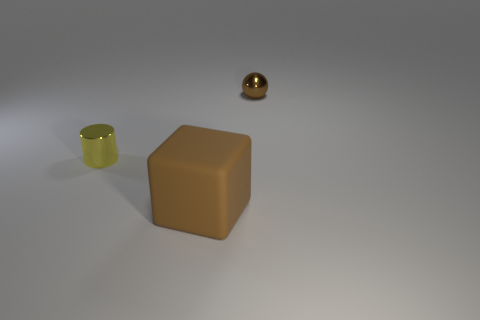What is the color of the object that is both right of the cylinder and behind the block?
Your response must be concise. Brown. Do the tiny object to the left of the small brown metallic thing and the small object on the right side of the tiny yellow metallic cylinder have the same material?
Give a very brief answer. Yes. Do the brown thing behind the yellow metallic cylinder and the small yellow metal cylinder have the same size?
Provide a short and direct response. Yes. Does the large thing have the same color as the metal object on the right side of the matte block?
Ensure brevity in your answer.  Yes. What shape is the large rubber thing that is the same color as the sphere?
Offer a very short reply. Cube. What shape is the big object?
Give a very brief answer. Cube. Do the small sphere and the matte block have the same color?
Give a very brief answer. Yes. How many things are small objects that are to the left of the small brown metallic sphere or tiny metal things?
Offer a terse response. 2. Are there more big brown rubber things in front of the tiny cylinder than tiny cyan cylinders?
Your answer should be very brief. Yes. Do the large matte object and the shiny thing to the left of the brown matte object have the same shape?
Keep it short and to the point. No. 